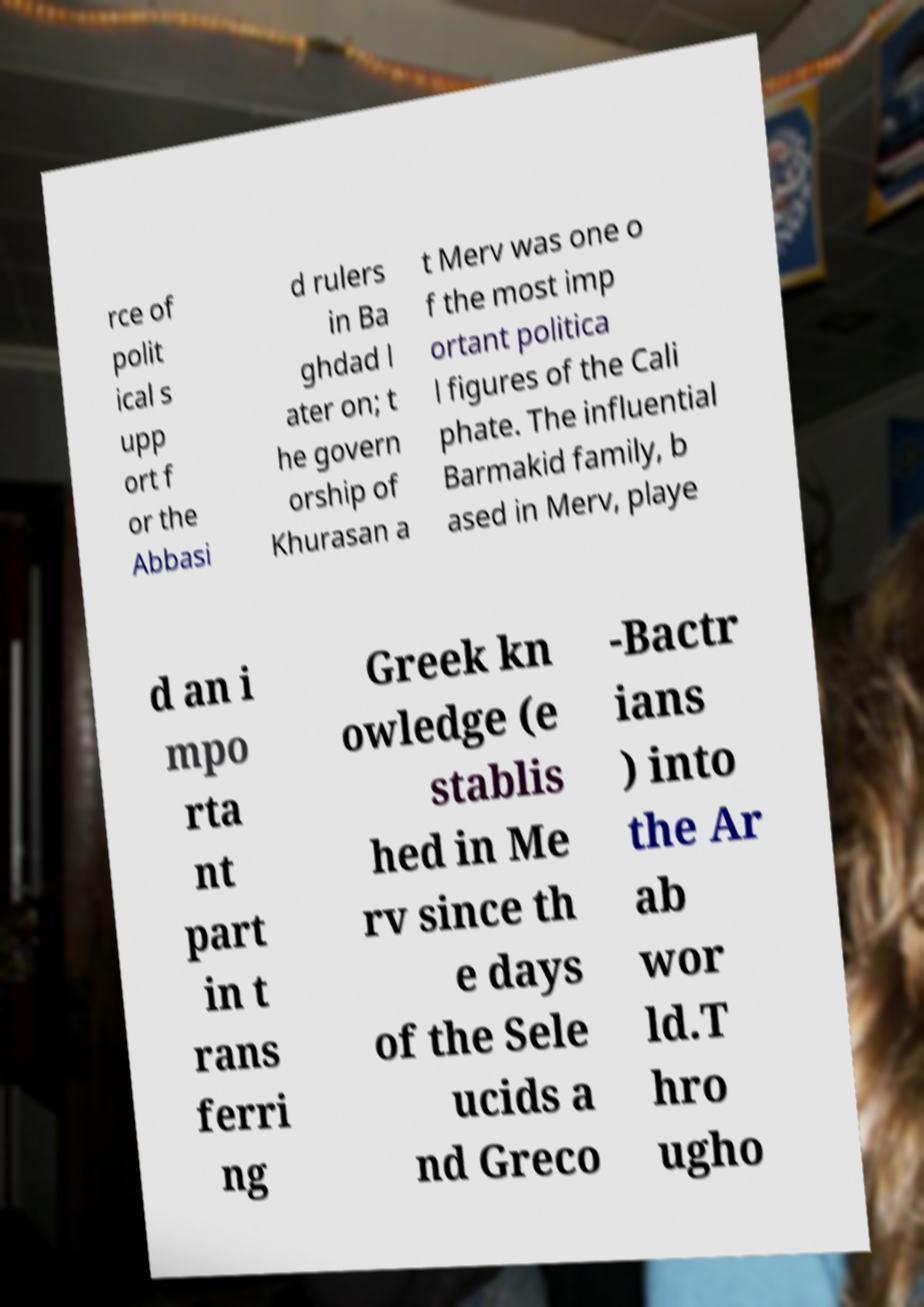For documentation purposes, I need the text within this image transcribed. Could you provide that? rce of polit ical s upp ort f or the Abbasi d rulers in Ba ghdad l ater on; t he govern orship of Khurasan a t Merv was one o f the most imp ortant politica l figures of the Cali phate. The influential Barmakid family, b ased in Merv, playe d an i mpo rta nt part in t rans ferri ng Greek kn owledge (e stablis hed in Me rv since th e days of the Sele ucids a nd Greco -Bactr ians ) into the Ar ab wor ld.T hro ugho 